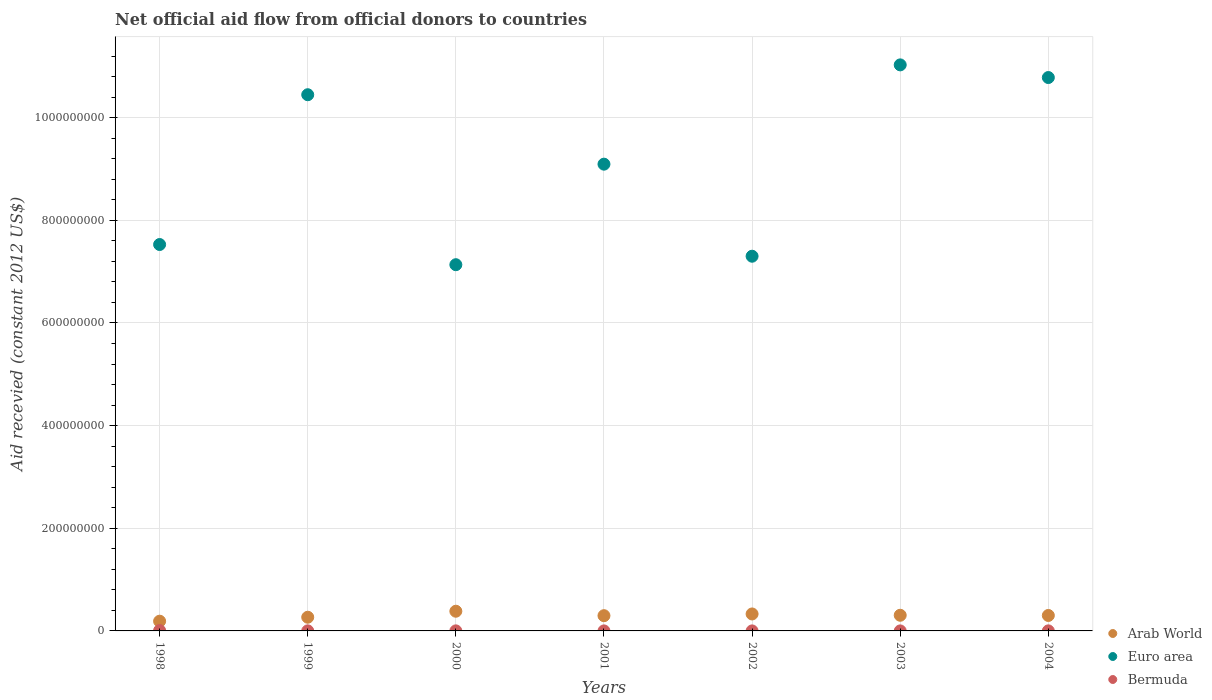Across all years, what is the maximum total aid received in Euro area?
Your response must be concise. 1.10e+09. Across all years, what is the minimum total aid received in Euro area?
Ensure brevity in your answer.  7.13e+08. In which year was the total aid received in Arab World maximum?
Provide a short and direct response. 2000. What is the total total aid received in Euro area in the graph?
Offer a very short reply. 6.33e+09. What is the difference between the total aid received in Arab World in 2003 and that in 2004?
Make the answer very short. 4.00e+05. What is the difference between the total aid received in Euro area in 2002 and the total aid received in Bermuda in 2000?
Offer a terse response. 7.30e+08. What is the average total aid received in Arab World per year?
Keep it short and to the point. 2.96e+07. In the year 1999, what is the difference between the total aid received in Bermuda and total aid received in Arab World?
Your response must be concise. -2.65e+07. What is the ratio of the total aid received in Bermuda in 1999 to that in 2004?
Keep it short and to the point. 1.18. What is the difference between the highest and the second highest total aid received in Euro area?
Offer a very short reply. 2.47e+07. What is the difference between the highest and the lowest total aid received in Arab World?
Your answer should be very brief. 1.94e+07. Is it the case that in every year, the sum of the total aid received in Bermuda and total aid received in Arab World  is greater than the total aid received in Euro area?
Your answer should be very brief. No. Does the total aid received in Bermuda monotonically increase over the years?
Offer a terse response. No. Is the total aid received in Euro area strictly greater than the total aid received in Arab World over the years?
Provide a succinct answer. Yes. Is the total aid received in Euro area strictly less than the total aid received in Bermuda over the years?
Offer a very short reply. No. How many years are there in the graph?
Provide a succinct answer. 7. Are the values on the major ticks of Y-axis written in scientific E-notation?
Provide a short and direct response. No. What is the title of the graph?
Your answer should be compact. Net official aid flow from official donors to countries. Does "Ukraine" appear as one of the legend labels in the graph?
Offer a terse response. No. What is the label or title of the X-axis?
Offer a very short reply. Years. What is the label or title of the Y-axis?
Make the answer very short. Aid recevied (constant 2012 US$). What is the Aid recevied (constant 2012 US$) in Arab World in 1998?
Ensure brevity in your answer.  1.90e+07. What is the Aid recevied (constant 2012 US$) in Euro area in 1998?
Offer a very short reply. 7.53e+08. What is the Aid recevied (constant 2012 US$) of Bermuda in 1998?
Your answer should be compact. 7.40e+05. What is the Aid recevied (constant 2012 US$) in Arab World in 1999?
Provide a short and direct response. 2.67e+07. What is the Aid recevied (constant 2012 US$) of Euro area in 1999?
Offer a terse response. 1.04e+09. What is the Aid recevied (constant 2012 US$) in Bermuda in 1999?
Ensure brevity in your answer.  1.30e+05. What is the Aid recevied (constant 2012 US$) of Arab World in 2000?
Offer a very short reply. 3.84e+07. What is the Aid recevied (constant 2012 US$) of Euro area in 2000?
Offer a very short reply. 7.13e+08. What is the Aid recevied (constant 2012 US$) in Bermuda in 2000?
Ensure brevity in your answer.  1.10e+05. What is the Aid recevied (constant 2012 US$) in Arab World in 2001?
Your answer should be compact. 2.97e+07. What is the Aid recevied (constant 2012 US$) of Euro area in 2001?
Your answer should be very brief. 9.09e+08. What is the Aid recevied (constant 2012 US$) in Arab World in 2002?
Ensure brevity in your answer.  3.30e+07. What is the Aid recevied (constant 2012 US$) of Euro area in 2002?
Your answer should be compact. 7.30e+08. What is the Aid recevied (constant 2012 US$) in Arab World in 2003?
Keep it short and to the point. 3.05e+07. What is the Aid recevied (constant 2012 US$) in Euro area in 2003?
Make the answer very short. 1.10e+09. What is the Aid recevied (constant 2012 US$) of Bermuda in 2003?
Your answer should be very brief. 4.00e+04. What is the Aid recevied (constant 2012 US$) in Arab World in 2004?
Offer a terse response. 3.01e+07. What is the Aid recevied (constant 2012 US$) of Euro area in 2004?
Your answer should be very brief. 1.08e+09. Across all years, what is the maximum Aid recevied (constant 2012 US$) of Arab World?
Give a very brief answer. 3.84e+07. Across all years, what is the maximum Aid recevied (constant 2012 US$) of Euro area?
Provide a succinct answer. 1.10e+09. Across all years, what is the maximum Aid recevied (constant 2012 US$) in Bermuda?
Your response must be concise. 7.40e+05. Across all years, what is the minimum Aid recevied (constant 2012 US$) in Arab World?
Ensure brevity in your answer.  1.90e+07. Across all years, what is the minimum Aid recevied (constant 2012 US$) in Euro area?
Your response must be concise. 7.13e+08. What is the total Aid recevied (constant 2012 US$) of Arab World in the graph?
Keep it short and to the point. 2.07e+08. What is the total Aid recevied (constant 2012 US$) in Euro area in the graph?
Keep it short and to the point. 6.33e+09. What is the total Aid recevied (constant 2012 US$) of Bermuda in the graph?
Give a very brief answer. 1.20e+06. What is the difference between the Aid recevied (constant 2012 US$) in Arab World in 1998 and that in 1999?
Make the answer very short. -7.71e+06. What is the difference between the Aid recevied (constant 2012 US$) of Euro area in 1998 and that in 1999?
Offer a very short reply. -2.92e+08. What is the difference between the Aid recevied (constant 2012 US$) in Bermuda in 1998 and that in 1999?
Your answer should be very brief. 6.10e+05. What is the difference between the Aid recevied (constant 2012 US$) of Arab World in 1998 and that in 2000?
Ensure brevity in your answer.  -1.94e+07. What is the difference between the Aid recevied (constant 2012 US$) in Euro area in 1998 and that in 2000?
Provide a succinct answer. 3.93e+07. What is the difference between the Aid recevied (constant 2012 US$) in Bermuda in 1998 and that in 2000?
Offer a terse response. 6.30e+05. What is the difference between the Aid recevied (constant 2012 US$) of Arab World in 1998 and that in 2001?
Your answer should be very brief. -1.07e+07. What is the difference between the Aid recevied (constant 2012 US$) of Euro area in 1998 and that in 2001?
Keep it short and to the point. -1.57e+08. What is the difference between the Aid recevied (constant 2012 US$) of Arab World in 1998 and that in 2002?
Offer a very short reply. -1.41e+07. What is the difference between the Aid recevied (constant 2012 US$) in Euro area in 1998 and that in 2002?
Offer a very short reply. 2.28e+07. What is the difference between the Aid recevied (constant 2012 US$) in Bermuda in 1998 and that in 2002?
Provide a short and direct response. 7.10e+05. What is the difference between the Aid recevied (constant 2012 US$) in Arab World in 1998 and that in 2003?
Offer a terse response. -1.15e+07. What is the difference between the Aid recevied (constant 2012 US$) in Euro area in 1998 and that in 2003?
Your response must be concise. -3.50e+08. What is the difference between the Aid recevied (constant 2012 US$) in Bermuda in 1998 and that in 2003?
Keep it short and to the point. 7.00e+05. What is the difference between the Aid recevied (constant 2012 US$) of Arab World in 1998 and that in 2004?
Offer a terse response. -1.11e+07. What is the difference between the Aid recevied (constant 2012 US$) of Euro area in 1998 and that in 2004?
Your answer should be compact. -3.25e+08. What is the difference between the Aid recevied (constant 2012 US$) in Bermuda in 1998 and that in 2004?
Your answer should be compact. 6.30e+05. What is the difference between the Aid recevied (constant 2012 US$) of Arab World in 1999 and that in 2000?
Your answer should be very brief. -1.17e+07. What is the difference between the Aid recevied (constant 2012 US$) in Euro area in 1999 and that in 2000?
Offer a terse response. 3.31e+08. What is the difference between the Aid recevied (constant 2012 US$) of Bermuda in 1999 and that in 2000?
Offer a terse response. 2.00e+04. What is the difference between the Aid recevied (constant 2012 US$) in Arab World in 1999 and that in 2001?
Keep it short and to the point. -3.03e+06. What is the difference between the Aid recevied (constant 2012 US$) in Euro area in 1999 and that in 2001?
Keep it short and to the point. 1.35e+08. What is the difference between the Aid recevied (constant 2012 US$) in Arab World in 1999 and that in 2002?
Make the answer very short. -6.38e+06. What is the difference between the Aid recevied (constant 2012 US$) in Euro area in 1999 and that in 2002?
Offer a very short reply. 3.15e+08. What is the difference between the Aid recevied (constant 2012 US$) in Arab World in 1999 and that in 2003?
Your answer should be compact. -3.83e+06. What is the difference between the Aid recevied (constant 2012 US$) of Euro area in 1999 and that in 2003?
Give a very brief answer. -5.82e+07. What is the difference between the Aid recevied (constant 2012 US$) in Arab World in 1999 and that in 2004?
Ensure brevity in your answer.  -3.43e+06. What is the difference between the Aid recevied (constant 2012 US$) of Euro area in 1999 and that in 2004?
Offer a very short reply. -3.35e+07. What is the difference between the Aid recevied (constant 2012 US$) of Arab World in 2000 and that in 2001?
Provide a short and direct response. 8.66e+06. What is the difference between the Aid recevied (constant 2012 US$) of Euro area in 2000 and that in 2001?
Your answer should be compact. -1.96e+08. What is the difference between the Aid recevied (constant 2012 US$) of Arab World in 2000 and that in 2002?
Provide a short and direct response. 5.31e+06. What is the difference between the Aid recevied (constant 2012 US$) of Euro area in 2000 and that in 2002?
Make the answer very short. -1.65e+07. What is the difference between the Aid recevied (constant 2012 US$) in Bermuda in 2000 and that in 2002?
Give a very brief answer. 8.00e+04. What is the difference between the Aid recevied (constant 2012 US$) in Arab World in 2000 and that in 2003?
Provide a succinct answer. 7.86e+06. What is the difference between the Aid recevied (constant 2012 US$) of Euro area in 2000 and that in 2003?
Make the answer very short. -3.89e+08. What is the difference between the Aid recevied (constant 2012 US$) in Bermuda in 2000 and that in 2003?
Keep it short and to the point. 7.00e+04. What is the difference between the Aid recevied (constant 2012 US$) of Arab World in 2000 and that in 2004?
Give a very brief answer. 8.26e+06. What is the difference between the Aid recevied (constant 2012 US$) of Euro area in 2000 and that in 2004?
Make the answer very short. -3.65e+08. What is the difference between the Aid recevied (constant 2012 US$) of Bermuda in 2000 and that in 2004?
Offer a terse response. 0. What is the difference between the Aid recevied (constant 2012 US$) of Arab World in 2001 and that in 2002?
Your answer should be very brief. -3.35e+06. What is the difference between the Aid recevied (constant 2012 US$) of Euro area in 2001 and that in 2002?
Make the answer very short. 1.79e+08. What is the difference between the Aid recevied (constant 2012 US$) in Bermuda in 2001 and that in 2002?
Offer a very short reply. 10000. What is the difference between the Aid recevied (constant 2012 US$) in Arab World in 2001 and that in 2003?
Make the answer very short. -8.00e+05. What is the difference between the Aid recevied (constant 2012 US$) in Euro area in 2001 and that in 2003?
Ensure brevity in your answer.  -1.93e+08. What is the difference between the Aid recevied (constant 2012 US$) in Arab World in 2001 and that in 2004?
Your answer should be compact. -4.00e+05. What is the difference between the Aid recevied (constant 2012 US$) in Euro area in 2001 and that in 2004?
Ensure brevity in your answer.  -1.69e+08. What is the difference between the Aid recevied (constant 2012 US$) in Bermuda in 2001 and that in 2004?
Give a very brief answer. -7.00e+04. What is the difference between the Aid recevied (constant 2012 US$) in Arab World in 2002 and that in 2003?
Offer a very short reply. 2.55e+06. What is the difference between the Aid recevied (constant 2012 US$) in Euro area in 2002 and that in 2003?
Your answer should be very brief. -3.73e+08. What is the difference between the Aid recevied (constant 2012 US$) of Bermuda in 2002 and that in 2003?
Your answer should be very brief. -10000. What is the difference between the Aid recevied (constant 2012 US$) in Arab World in 2002 and that in 2004?
Offer a very short reply. 2.95e+06. What is the difference between the Aid recevied (constant 2012 US$) in Euro area in 2002 and that in 2004?
Keep it short and to the point. -3.48e+08. What is the difference between the Aid recevied (constant 2012 US$) in Euro area in 2003 and that in 2004?
Your answer should be compact. 2.47e+07. What is the difference between the Aid recevied (constant 2012 US$) of Arab World in 1998 and the Aid recevied (constant 2012 US$) of Euro area in 1999?
Ensure brevity in your answer.  -1.03e+09. What is the difference between the Aid recevied (constant 2012 US$) in Arab World in 1998 and the Aid recevied (constant 2012 US$) in Bermuda in 1999?
Keep it short and to the point. 1.88e+07. What is the difference between the Aid recevied (constant 2012 US$) of Euro area in 1998 and the Aid recevied (constant 2012 US$) of Bermuda in 1999?
Make the answer very short. 7.53e+08. What is the difference between the Aid recevied (constant 2012 US$) in Arab World in 1998 and the Aid recevied (constant 2012 US$) in Euro area in 2000?
Provide a short and direct response. -6.95e+08. What is the difference between the Aid recevied (constant 2012 US$) in Arab World in 1998 and the Aid recevied (constant 2012 US$) in Bermuda in 2000?
Provide a short and direct response. 1.88e+07. What is the difference between the Aid recevied (constant 2012 US$) of Euro area in 1998 and the Aid recevied (constant 2012 US$) of Bermuda in 2000?
Your response must be concise. 7.53e+08. What is the difference between the Aid recevied (constant 2012 US$) of Arab World in 1998 and the Aid recevied (constant 2012 US$) of Euro area in 2001?
Your answer should be compact. -8.90e+08. What is the difference between the Aid recevied (constant 2012 US$) in Arab World in 1998 and the Aid recevied (constant 2012 US$) in Bermuda in 2001?
Keep it short and to the point. 1.89e+07. What is the difference between the Aid recevied (constant 2012 US$) of Euro area in 1998 and the Aid recevied (constant 2012 US$) of Bermuda in 2001?
Provide a succinct answer. 7.53e+08. What is the difference between the Aid recevied (constant 2012 US$) in Arab World in 1998 and the Aid recevied (constant 2012 US$) in Euro area in 2002?
Make the answer very short. -7.11e+08. What is the difference between the Aid recevied (constant 2012 US$) of Arab World in 1998 and the Aid recevied (constant 2012 US$) of Bermuda in 2002?
Ensure brevity in your answer.  1.89e+07. What is the difference between the Aid recevied (constant 2012 US$) of Euro area in 1998 and the Aid recevied (constant 2012 US$) of Bermuda in 2002?
Your answer should be very brief. 7.53e+08. What is the difference between the Aid recevied (constant 2012 US$) in Arab World in 1998 and the Aid recevied (constant 2012 US$) in Euro area in 2003?
Your answer should be compact. -1.08e+09. What is the difference between the Aid recevied (constant 2012 US$) of Arab World in 1998 and the Aid recevied (constant 2012 US$) of Bermuda in 2003?
Your answer should be compact. 1.89e+07. What is the difference between the Aid recevied (constant 2012 US$) of Euro area in 1998 and the Aid recevied (constant 2012 US$) of Bermuda in 2003?
Ensure brevity in your answer.  7.53e+08. What is the difference between the Aid recevied (constant 2012 US$) in Arab World in 1998 and the Aid recevied (constant 2012 US$) in Euro area in 2004?
Provide a short and direct response. -1.06e+09. What is the difference between the Aid recevied (constant 2012 US$) in Arab World in 1998 and the Aid recevied (constant 2012 US$) in Bermuda in 2004?
Ensure brevity in your answer.  1.88e+07. What is the difference between the Aid recevied (constant 2012 US$) of Euro area in 1998 and the Aid recevied (constant 2012 US$) of Bermuda in 2004?
Provide a short and direct response. 7.53e+08. What is the difference between the Aid recevied (constant 2012 US$) of Arab World in 1999 and the Aid recevied (constant 2012 US$) of Euro area in 2000?
Give a very brief answer. -6.87e+08. What is the difference between the Aid recevied (constant 2012 US$) in Arab World in 1999 and the Aid recevied (constant 2012 US$) in Bermuda in 2000?
Make the answer very short. 2.66e+07. What is the difference between the Aid recevied (constant 2012 US$) of Euro area in 1999 and the Aid recevied (constant 2012 US$) of Bermuda in 2000?
Your response must be concise. 1.04e+09. What is the difference between the Aid recevied (constant 2012 US$) in Arab World in 1999 and the Aid recevied (constant 2012 US$) in Euro area in 2001?
Offer a very short reply. -8.83e+08. What is the difference between the Aid recevied (constant 2012 US$) in Arab World in 1999 and the Aid recevied (constant 2012 US$) in Bermuda in 2001?
Make the answer very short. 2.66e+07. What is the difference between the Aid recevied (constant 2012 US$) in Euro area in 1999 and the Aid recevied (constant 2012 US$) in Bermuda in 2001?
Your answer should be very brief. 1.04e+09. What is the difference between the Aid recevied (constant 2012 US$) in Arab World in 1999 and the Aid recevied (constant 2012 US$) in Euro area in 2002?
Provide a succinct answer. -7.03e+08. What is the difference between the Aid recevied (constant 2012 US$) of Arab World in 1999 and the Aid recevied (constant 2012 US$) of Bermuda in 2002?
Provide a succinct answer. 2.66e+07. What is the difference between the Aid recevied (constant 2012 US$) in Euro area in 1999 and the Aid recevied (constant 2012 US$) in Bermuda in 2002?
Your answer should be compact. 1.04e+09. What is the difference between the Aid recevied (constant 2012 US$) of Arab World in 1999 and the Aid recevied (constant 2012 US$) of Euro area in 2003?
Offer a very short reply. -1.08e+09. What is the difference between the Aid recevied (constant 2012 US$) in Arab World in 1999 and the Aid recevied (constant 2012 US$) in Bermuda in 2003?
Provide a short and direct response. 2.66e+07. What is the difference between the Aid recevied (constant 2012 US$) of Euro area in 1999 and the Aid recevied (constant 2012 US$) of Bermuda in 2003?
Your answer should be very brief. 1.04e+09. What is the difference between the Aid recevied (constant 2012 US$) of Arab World in 1999 and the Aid recevied (constant 2012 US$) of Euro area in 2004?
Keep it short and to the point. -1.05e+09. What is the difference between the Aid recevied (constant 2012 US$) of Arab World in 1999 and the Aid recevied (constant 2012 US$) of Bermuda in 2004?
Your response must be concise. 2.66e+07. What is the difference between the Aid recevied (constant 2012 US$) of Euro area in 1999 and the Aid recevied (constant 2012 US$) of Bermuda in 2004?
Provide a short and direct response. 1.04e+09. What is the difference between the Aid recevied (constant 2012 US$) in Arab World in 2000 and the Aid recevied (constant 2012 US$) in Euro area in 2001?
Give a very brief answer. -8.71e+08. What is the difference between the Aid recevied (constant 2012 US$) of Arab World in 2000 and the Aid recevied (constant 2012 US$) of Bermuda in 2001?
Provide a succinct answer. 3.83e+07. What is the difference between the Aid recevied (constant 2012 US$) in Euro area in 2000 and the Aid recevied (constant 2012 US$) in Bermuda in 2001?
Keep it short and to the point. 7.13e+08. What is the difference between the Aid recevied (constant 2012 US$) of Arab World in 2000 and the Aid recevied (constant 2012 US$) of Euro area in 2002?
Offer a very short reply. -6.92e+08. What is the difference between the Aid recevied (constant 2012 US$) of Arab World in 2000 and the Aid recevied (constant 2012 US$) of Bermuda in 2002?
Your answer should be very brief. 3.83e+07. What is the difference between the Aid recevied (constant 2012 US$) in Euro area in 2000 and the Aid recevied (constant 2012 US$) in Bermuda in 2002?
Your response must be concise. 7.13e+08. What is the difference between the Aid recevied (constant 2012 US$) in Arab World in 2000 and the Aid recevied (constant 2012 US$) in Euro area in 2003?
Offer a very short reply. -1.06e+09. What is the difference between the Aid recevied (constant 2012 US$) of Arab World in 2000 and the Aid recevied (constant 2012 US$) of Bermuda in 2003?
Offer a terse response. 3.83e+07. What is the difference between the Aid recevied (constant 2012 US$) in Euro area in 2000 and the Aid recevied (constant 2012 US$) in Bermuda in 2003?
Provide a short and direct response. 7.13e+08. What is the difference between the Aid recevied (constant 2012 US$) of Arab World in 2000 and the Aid recevied (constant 2012 US$) of Euro area in 2004?
Provide a succinct answer. -1.04e+09. What is the difference between the Aid recevied (constant 2012 US$) in Arab World in 2000 and the Aid recevied (constant 2012 US$) in Bermuda in 2004?
Your answer should be very brief. 3.82e+07. What is the difference between the Aid recevied (constant 2012 US$) in Euro area in 2000 and the Aid recevied (constant 2012 US$) in Bermuda in 2004?
Your response must be concise. 7.13e+08. What is the difference between the Aid recevied (constant 2012 US$) in Arab World in 2001 and the Aid recevied (constant 2012 US$) in Euro area in 2002?
Your answer should be very brief. -7.00e+08. What is the difference between the Aid recevied (constant 2012 US$) in Arab World in 2001 and the Aid recevied (constant 2012 US$) in Bermuda in 2002?
Provide a succinct answer. 2.97e+07. What is the difference between the Aid recevied (constant 2012 US$) in Euro area in 2001 and the Aid recevied (constant 2012 US$) in Bermuda in 2002?
Make the answer very short. 9.09e+08. What is the difference between the Aid recevied (constant 2012 US$) in Arab World in 2001 and the Aid recevied (constant 2012 US$) in Euro area in 2003?
Ensure brevity in your answer.  -1.07e+09. What is the difference between the Aid recevied (constant 2012 US$) in Arab World in 2001 and the Aid recevied (constant 2012 US$) in Bermuda in 2003?
Offer a terse response. 2.97e+07. What is the difference between the Aid recevied (constant 2012 US$) of Euro area in 2001 and the Aid recevied (constant 2012 US$) of Bermuda in 2003?
Give a very brief answer. 9.09e+08. What is the difference between the Aid recevied (constant 2012 US$) in Arab World in 2001 and the Aid recevied (constant 2012 US$) in Euro area in 2004?
Offer a very short reply. -1.05e+09. What is the difference between the Aid recevied (constant 2012 US$) in Arab World in 2001 and the Aid recevied (constant 2012 US$) in Bermuda in 2004?
Your answer should be very brief. 2.96e+07. What is the difference between the Aid recevied (constant 2012 US$) of Euro area in 2001 and the Aid recevied (constant 2012 US$) of Bermuda in 2004?
Your answer should be compact. 9.09e+08. What is the difference between the Aid recevied (constant 2012 US$) in Arab World in 2002 and the Aid recevied (constant 2012 US$) in Euro area in 2003?
Your answer should be compact. -1.07e+09. What is the difference between the Aid recevied (constant 2012 US$) in Arab World in 2002 and the Aid recevied (constant 2012 US$) in Bermuda in 2003?
Provide a short and direct response. 3.30e+07. What is the difference between the Aid recevied (constant 2012 US$) of Euro area in 2002 and the Aid recevied (constant 2012 US$) of Bermuda in 2003?
Ensure brevity in your answer.  7.30e+08. What is the difference between the Aid recevied (constant 2012 US$) of Arab World in 2002 and the Aid recevied (constant 2012 US$) of Euro area in 2004?
Make the answer very short. -1.05e+09. What is the difference between the Aid recevied (constant 2012 US$) in Arab World in 2002 and the Aid recevied (constant 2012 US$) in Bermuda in 2004?
Give a very brief answer. 3.29e+07. What is the difference between the Aid recevied (constant 2012 US$) in Euro area in 2002 and the Aid recevied (constant 2012 US$) in Bermuda in 2004?
Your answer should be compact. 7.30e+08. What is the difference between the Aid recevied (constant 2012 US$) of Arab World in 2003 and the Aid recevied (constant 2012 US$) of Euro area in 2004?
Provide a short and direct response. -1.05e+09. What is the difference between the Aid recevied (constant 2012 US$) of Arab World in 2003 and the Aid recevied (constant 2012 US$) of Bermuda in 2004?
Your answer should be compact. 3.04e+07. What is the difference between the Aid recevied (constant 2012 US$) in Euro area in 2003 and the Aid recevied (constant 2012 US$) in Bermuda in 2004?
Give a very brief answer. 1.10e+09. What is the average Aid recevied (constant 2012 US$) in Arab World per year?
Make the answer very short. 2.96e+07. What is the average Aid recevied (constant 2012 US$) in Euro area per year?
Offer a terse response. 9.04e+08. What is the average Aid recevied (constant 2012 US$) of Bermuda per year?
Your response must be concise. 1.71e+05. In the year 1998, what is the difference between the Aid recevied (constant 2012 US$) of Arab World and Aid recevied (constant 2012 US$) of Euro area?
Make the answer very short. -7.34e+08. In the year 1998, what is the difference between the Aid recevied (constant 2012 US$) of Arab World and Aid recevied (constant 2012 US$) of Bermuda?
Give a very brief answer. 1.82e+07. In the year 1998, what is the difference between the Aid recevied (constant 2012 US$) of Euro area and Aid recevied (constant 2012 US$) of Bermuda?
Your answer should be very brief. 7.52e+08. In the year 1999, what is the difference between the Aid recevied (constant 2012 US$) in Arab World and Aid recevied (constant 2012 US$) in Euro area?
Provide a succinct answer. -1.02e+09. In the year 1999, what is the difference between the Aid recevied (constant 2012 US$) of Arab World and Aid recevied (constant 2012 US$) of Bermuda?
Give a very brief answer. 2.65e+07. In the year 1999, what is the difference between the Aid recevied (constant 2012 US$) in Euro area and Aid recevied (constant 2012 US$) in Bermuda?
Your response must be concise. 1.04e+09. In the year 2000, what is the difference between the Aid recevied (constant 2012 US$) in Arab World and Aid recevied (constant 2012 US$) in Euro area?
Offer a terse response. -6.75e+08. In the year 2000, what is the difference between the Aid recevied (constant 2012 US$) of Arab World and Aid recevied (constant 2012 US$) of Bermuda?
Ensure brevity in your answer.  3.82e+07. In the year 2000, what is the difference between the Aid recevied (constant 2012 US$) in Euro area and Aid recevied (constant 2012 US$) in Bermuda?
Ensure brevity in your answer.  7.13e+08. In the year 2001, what is the difference between the Aid recevied (constant 2012 US$) of Arab World and Aid recevied (constant 2012 US$) of Euro area?
Offer a very short reply. -8.80e+08. In the year 2001, what is the difference between the Aid recevied (constant 2012 US$) of Arab World and Aid recevied (constant 2012 US$) of Bermuda?
Offer a very short reply. 2.97e+07. In the year 2001, what is the difference between the Aid recevied (constant 2012 US$) in Euro area and Aid recevied (constant 2012 US$) in Bermuda?
Offer a terse response. 9.09e+08. In the year 2002, what is the difference between the Aid recevied (constant 2012 US$) in Arab World and Aid recevied (constant 2012 US$) in Euro area?
Keep it short and to the point. -6.97e+08. In the year 2002, what is the difference between the Aid recevied (constant 2012 US$) in Arab World and Aid recevied (constant 2012 US$) in Bermuda?
Provide a short and direct response. 3.30e+07. In the year 2002, what is the difference between the Aid recevied (constant 2012 US$) of Euro area and Aid recevied (constant 2012 US$) of Bermuda?
Keep it short and to the point. 7.30e+08. In the year 2003, what is the difference between the Aid recevied (constant 2012 US$) of Arab World and Aid recevied (constant 2012 US$) of Euro area?
Keep it short and to the point. -1.07e+09. In the year 2003, what is the difference between the Aid recevied (constant 2012 US$) of Arab World and Aid recevied (constant 2012 US$) of Bermuda?
Provide a short and direct response. 3.05e+07. In the year 2003, what is the difference between the Aid recevied (constant 2012 US$) of Euro area and Aid recevied (constant 2012 US$) of Bermuda?
Offer a terse response. 1.10e+09. In the year 2004, what is the difference between the Aid recevied (constant 2012 US$) of Arab World and Aid recevied (constant 2012 US$) of Euro area?
Your answer should be very brief. -1.05e+09. In the year 2004, what is the difference between the Aid recevied (constant 2012 US$) of Arab World and Aid recevied (constant 2012 US$) of Bermuda?
Give a very brief answer. 3.00e+07. In the year 2004, what is the difference between the Aid recevied (constant 2012 US$) of Euro area and Aid recevied (constant 2012 US$) of Bermuda?
Offer a terse response. 1.08e+09. What is the ratio of the Aid recevied (constant 2012 US$) of Arab World in 1998 to that in 1999?
Make the answer very short. 0.71. What is the ratio of the Aid recevied (constant 2012 US$) of Euro area in 1998 to that in 1999?
Provide a succinct answer. 0.72. What is the ratio of the Aid recevied (constant 2012 US$) of Bermuda in 1998 to that in 1999?
Ensure brevity in your answer.  5.69. What is the ratio of the Aid recevied (constant 2012 US$) in Arab World in 1998 to that in 2000?
Ensure brevity in your answer.  0.49. What is the ratio of the Aid recevied (constant 2012 US$) of Euro area in 1998 to that in 2000?
Ensure brevity in your answer.  1.06. What is the ratio of the Aid recevied (constant 2012 US$) in Bermuda in 1998 to that in 2000?
Offer a very short reply. 6.73. What is the ratio of the Aid recevied (constant 2012 US$) in Arab World in 1998 to that in 2001?
Provide a succinct answer. 0.64. What is the ratio of the Aid recevied (constant 2012 US$) of Euro area in 1998 to that in 2001?
Your answer should be compact. 0.83. What is the ratio of the Aid recevied (constant 2012 US$) of Bermuda in 1998 to that in 2001?
Make the answer very short. 18.5. What is the ratio of the Aid recevied (constant 2012 US$) in Arab World in 1998 to that in 2002?
Your answer should be compact. 0.57. What is the ratio of the Aid recevied (constant 2012 US$) in Euro area in 1998 to that in 2002?
Offer a terse response. 1.03. What is the ratio of the Aid recevied (constant 2012 US$) of Bermuda in 1998 to that in 2002?
Your answer should be very brief. 24.67. What is the ratio of the Aid recevied (constant 2012 US$) of Arab World in 1998 to that in 2003?
Your response must be concise. 0.62. What is the ratio of the Aid recevied (constant 2012 US$) in Euro area in 1998 to that in 2003?
Make the answer very short. 0.68. What is the ratio of the Aid recevied (constant 2012 US$) in Bermuda in 1998 to that in 2003?
Your answer should be compact. 18.5. What is the ratio of the Aid recevied (constant 2012 US$) in Arab World in 1998 to that in 2004?
Offer a terse response. 0.63. What is the ratio of the Aid recevied (constant 2012 US$) of Euro area in 1998 to that in 2004?
Ensure brevity in your answer.  0.7. What is the ratio of the Aid recevied (constant 2012 US$) in Bermuda in 1998 to that in 2004?
Offer a terse response. 6.73. What is the ratio of the Aid recevied (constant 2012 US$) in Arab World in 1999 to that in 2000?
Keep it short and to the point. 0.7. What is the ratio of the Aid recevied (constant 2012 US$) of Euro area in 1999 to that in 2000?
Your answer should be very brief. 1.46. What is the ratio of the Aid recevied (constant 2012 US$) of Bermuda in 1999 to that in 2000?
Ensure brevity in your answer.  1.18. What is the ratio of the Aid recevied (constant 2012 US$) of Arab World in 1999 to that in 2001?
Provide a succinct answer. 0.9. What is the ratio of the Aid recevied (constant 2012 US$) of Euro area in 1999 to that in 2001?
Your answer should be compact. 1.15. What is the ratio of the Aid recevied (constant 2012 US$) of Arab World in 1999 to that in 2002?
Give a very brief answer. 0.81. What is the ratio of the Aid recevied (constant 2012 US$) of Euro area in 1999 to that in 2002?
Give a very brief answer. 1.43. What is the ratio of the Aid recevied (constant 2012 US$) in Bermuda in 1999 to that in 2002?
Your answer should be compact. 4.33. What is the ratio of the Aid recevied (constant 2012 US$) in Arab World in 1999 to that in 2003?
Your response must be concise. 0.87. What is the ratio of the Aid recevied (constant 2012 US$) in Euro area in 1999 to that in 2003?
Give a very brief answer. 0.95. What is the ratio of the Aid recevied (constant 2012 US$) of Arab World in 1999 to that in 2004?
Your answer should be compact. 0.89. What is the ratio of the Aid recevied (constant 2012 US$) of Euro area in 1999 to that in 2004?
Your response must be concise. 0.97. What is the ratio of the Aid recevied (constant 2012 US$) in Bermuda in 1999 to that in 2004?
Offer a very short reply. 1.18. What is the ratio of the Aid recevied (constant 2012 US$) in Arab World in 2000 to that in 2001?
Give a very brief answer. 1.29. What is the ratio of the Aid recevied (constant 2012 US$) of Euro area in 2000 to that in 2001?
Offer a very short reply. 0.78. What is the ratio of the Aid recevied (constant 2012 US$) of Bermuda in 2000 to that in 2001?
Give a very brief answer. 2.75. What is the ratio of the Aid recevied (constant 2012 US$) in Arab World in 2000 to that in 2002?
Give a very brief answer. 1.16. What is the ratio of the Aid recevied (constant 2012 US$) in Euro area in 2000 to that in 2002?
Provide a short and direct response. 0.98. What is the ratio of the Aid recevied (constant 2012 US$) of Bermuda in 2000 to that in 2002?
Your answer should be very brief. 3.67. What is the ratio of the Aid recevied (constant 2012 US$) in Arab World in 2000 to that in 2003?
Provide a short and direct response. 1.26. What is the ratio of the Aid recevied (constant 2012 US$) of Euro area in 2000 to that in 2003?
Keep it short and to the point. 0.65. What is the ratio of the Aid recevied (constant 2012 US$) in Bermuda in 2000 to that in 2003?
Provide a succinct answer. 2.75. What is the ratio of the Aid recevied (constant 2012 US$) in Arab World in 2000 to that in 2004?
Provide a succinct answer. 1.27. What is the ratio of the Aid recevied (constant 2012 US$) of Euro area in 2000 to that in 2004?
Ensure brevity in your answer.  0.66. What is the ratio of the Aid recevied (constant 2012 US$) of Arab World in 2001 to that in 2002?
Offer a terse response. 0.9. What is the ratio of the Aid recevied (constant 2012 US$) in Euro area in 2001 to that in 2002?
Keep it short and to the point. 1.25. What is the ratio of the Aid recevied (constant 2012 US$) in Bermuda in 2001 to that in 2002?
Your response must be concise. 1.33. What is the ratio of the Aid recevied (constant 2012 US$) of Arab World in 2001 to that in 2003?
Keep it short and to the point. 0.97. What is the ratio of the Aid recevied (constant 2012 US$) of Euro area in 2001 to that in 2003?
Offer a terse response. 0.82. What is the ratio of the Aid recevied (constant 2012 US$) in Bermuda in 2001 to that in 2003?
Provide a succinct answer. 1. What is the ratio of the Aid recevied (constant 2012 US$) in Arab World in 2001 to that in 2004?
Offer a terse response. 0.99. What is the ratio of the Aid recevied (constant 2012 US$) of Euro area in 2001 to that in 2004?
Keep it short and to the point. 0.84. What is the ratio of the Aid recevied (constant 2012 US$) of Bermuda in 2001 to that in 2004?
Make the answer very short. 0.36. What is the ratio of the Aid recevied (constant 2012 US$) of Arab World in 2002 to that in 2003?
Give a very brief answer. 1.08. What is the ratio of the Aid recevied (constant 2012 US$) in Euro area in 2002 to that in 2003?
Offer a very short reply. 0.66. What is the ratio of the Aid recevied (constant 2012 US$) of Arab World in 2002 to that in 2004?
Your answer should be compact. 1.1. What is the ratio of the Aid recevied (constant 2012 US$) in Euro area in 2002 to that in 2004?
Give a very brief answer. 0.68. What is the ratio of the Aid recevied (constant 2012 US$) in Bermuda in 2002 to that in 2004?
Ensure brevity in your answer.  0.27. What is the ratio of the Aid recevied (constant 2012 US$) of Arab World in 2003 to that in 2004?
Offer a very short reply. 1.01. What is the ratio of the Aid recevied (constant 2012 US$) of Euro area in 2003 to that in 2004?
Give a very brief answer. 1.02. What is the ratio of the Aid recevied (constant 2012 US$) of Bermuda in 2003 to that in 2004?
Provide a short and direct response. 0.36. What is the difference between the highest and the second highest Aid recevied (constant 2012 US$) of Arab World?
Your response must be concise. 5.31e+06. What is the difference between the highest and the second highest Aid recevied (constant 2012 US$) in Euro area?
Give a very brief answer. 2.47e+07. What is the difference between the highest and the lowest Aid recevied (constant 2012 US$) of Arab World?
Your response must be concise. 1.94e+07. What is the difference between the highest and the lowest Aid recevied (constant 2012 US$) of Euro area?
Give a very brief answer. 3.89e+08. What is the difference between the highest and the lowest Aid recevied (constant 2012 US$) in Bermuda?
Offer a very short reply. 7.10e+05. 